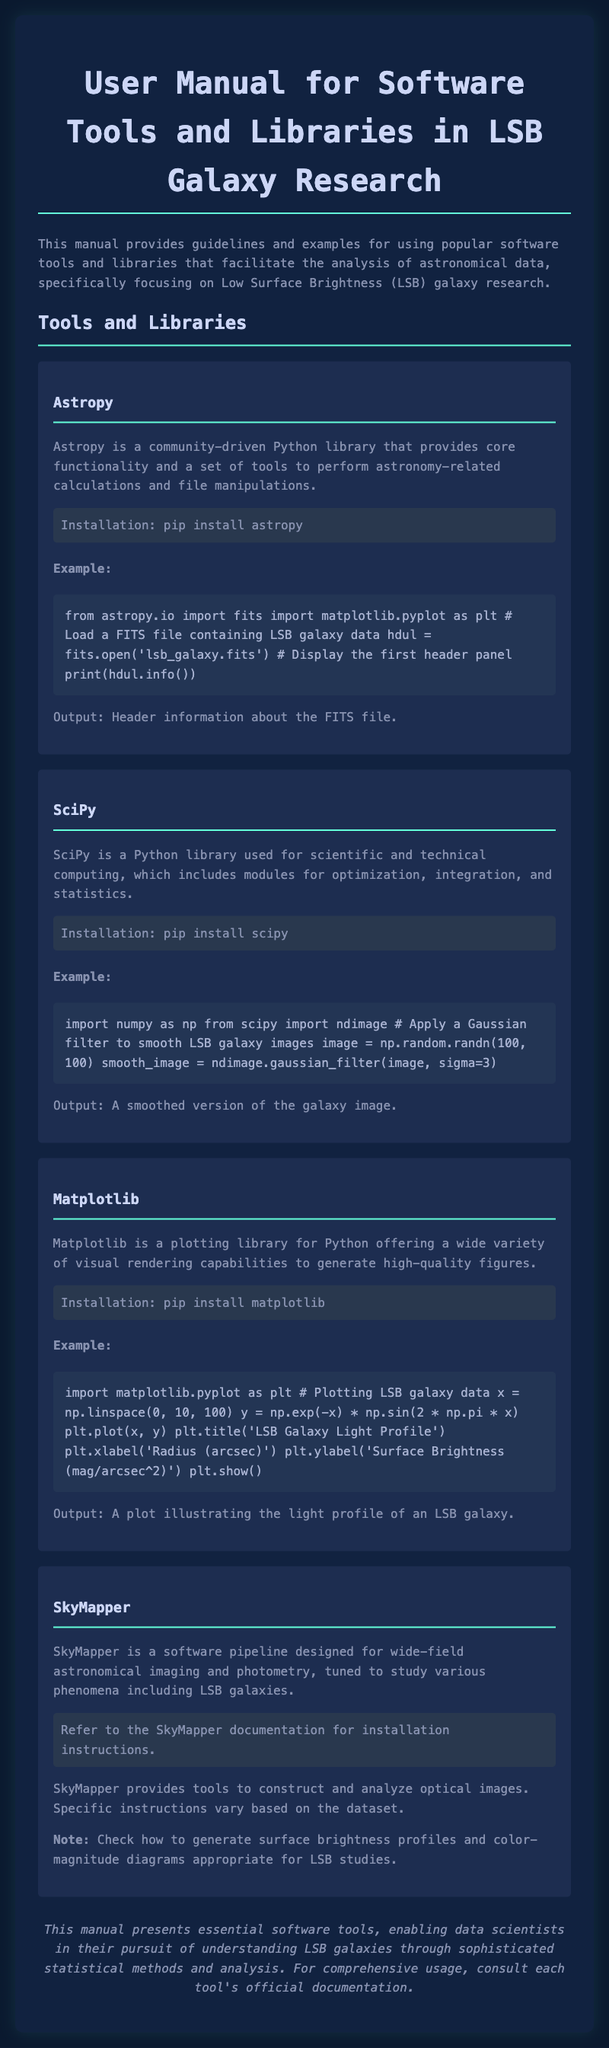What is the main title of the document? The title of the document is stated at the top of the HTML, reflecting the primary subject of the manual.
Answer: User Manual for Software Tools and Libraries in LSB Galaxy Research Which Python library is used for astronomical calculations? The document mentions a specific library and describes its purpose in astronomy-related tasks.
Answer: Astropy What is the installation command for SciPy? The installation command is explicitly listed in the section describing the SciPy library.
Answer: pip install scipy What kind of filter is applied to LSB galaxy images in the SciPy example? The document provides the specifics of the operations applied to LSB galaxy images using the library.
Answer: Gaussian filter What does the matplotlib example plot illustrate? The document elaborates on the data visualization aspect and specifies the content of the plot.
Answer: LSB Galaxy Light Profile Which software pipeline is designed for wide-field astronomical imaging? The document provides a name of a specific software designed for astronomical imaging and photometry.
Answer: SkyMapper What kind of outputs are produced by the examples in the manual? The outputs are described in relation to the examples given, outlining what results can be expected.
Answer: Header information, smoothed image, plot illustrating light profile What is the focus of SkyMapper according to the document? The document clarifies the main focus of the software pipeline in terms of its application.
Answer: LSB galaxies What is the installation method for Astropy? The document details the method of installation for this specific library, in a straightforward manner.
Answer: pip install astropy 